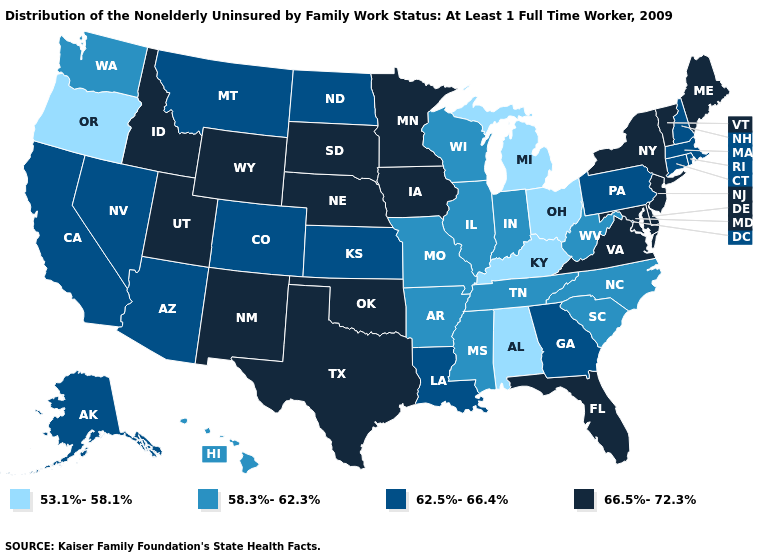How many symbols are there in the legend?
Be succinct. 4. Does South Dakota have the highest value in the MidWest?
Keep it brief. Yes. Name the states that have a value in the range 66.5%-72.3%?
Write a very short answer. Delaware, Florida, Idaho, Iowa, Maine, Maryland, Minnesota, Nebraska, New Jersey, New Mexico, New York, Oklahoma, South Dakota, Texas, Utah, Vermont, Virginia, Wyoming. Among the states that border South Carolina , which have the highest value?
Short answer required. Georgia. What is the value of Mississippi?
Be succinct. 58.3%-62.3%. What is the lowest value in the USA?
Quick response, please. 53.1%-58.1%. Among the states that border Maryland , does Delaware have the lowest value?
Quick response, please. No. Name the states that have a value in the range 58.3%-62.3%?
Concise answer only. Arkansas, Hawaii, Illinois, Indiana, Mississippi, Missouri, North Carolina, South Carolina, Tennessee, Washington, West Virginia, Wisconsin. Name the states that have a value in the range 66.5%-72.3%?
Short answer required. Delaware, Florida, Idaho, Iowa, Maine, Maryland, Minnesota, Nebraska, New Jersey, New Mexico, New York, Oklahoma, South Dakota, Texas, Utah, Vermont, Virginia, Wyoming. Does Texas have a lower value than New Mexico?
Concise answer only. No. Name the states that have a value in the range 66.5%-72.3%?
Be succinct. Delaware, Florida, Idaho, Iowa, Maine, Maryland, Minnesota, Nebraska, New Jersey, New Mexico, New York, Oklahoma, South Dakota, Texas, Utah, Vermont, Virginia, Wyoming. Which states hav the highest value in the West?
Short answer required. Idaho, New Mexico, Utah, Wyoming. What is the value of Florida?
Short answer required. 66.5%-72.3%. What is the highest value in the USA?
Write a very short answer. 66.5%-72.3%. Name the states that have a value in the range 53.1%-58.1%?
Answer briefly. Alabama, Kentucky, Michigan, Ohio, Oregon. 